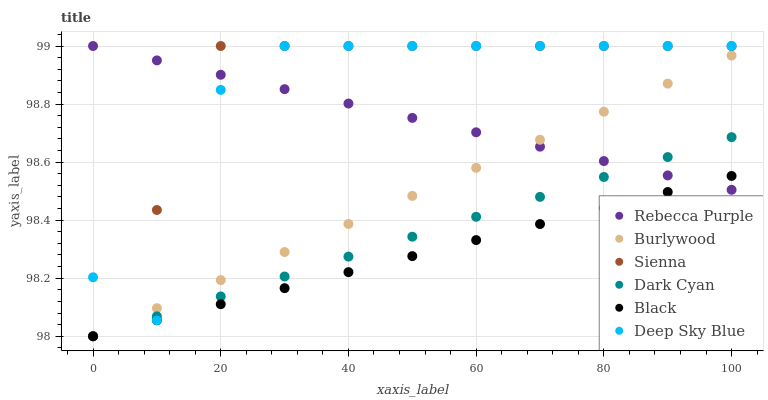Does Black have the minimum area under the curve?
Answer yes or no. Yes. Does Sienna have the maximum area under the curve?
Answer yes or no. Yes. Does Sienna have the minimum area under the curve?
Answer yes or no. No. Does Black have the maximum area under the curve?
Answer yes or no. No. Is Rebecca Purple the smoothest?
Answer yes or no. Yes. Is Deep Sky Blue the roughest?
Answer yes or no. Yes. Is Sienna the smoothest?
Answer yes or no. No. Is Sienna the roughest?
Answer yes or no. No. Does Burlywood have the lowest value?
Answer yes or no. Yes. Does Sienna have the lowest value?
Answer yes or no. No. Does Deep Sky Blue have the highest value?
Answer yes or no. Yes. Does Black have the highest value?
Answer yes or no. No. Is Dark Cyan less than Sienna?
Answer yes or no. Yes. Is Deep Sky Blue greater than Black?
Answer yes or no. Yes. Does Dark Cyan intersect Deep Sky Blue?
Answer yes or no. Yes. Is Dark Cyan less than Deep Sky Blue?
Answer yes or no. No. Is Dark Cyan greater than Deep Sky Blue?
Answer yes or no. No. Does Dark Cyan intersect Sienna?
Answer yes or no. No. 